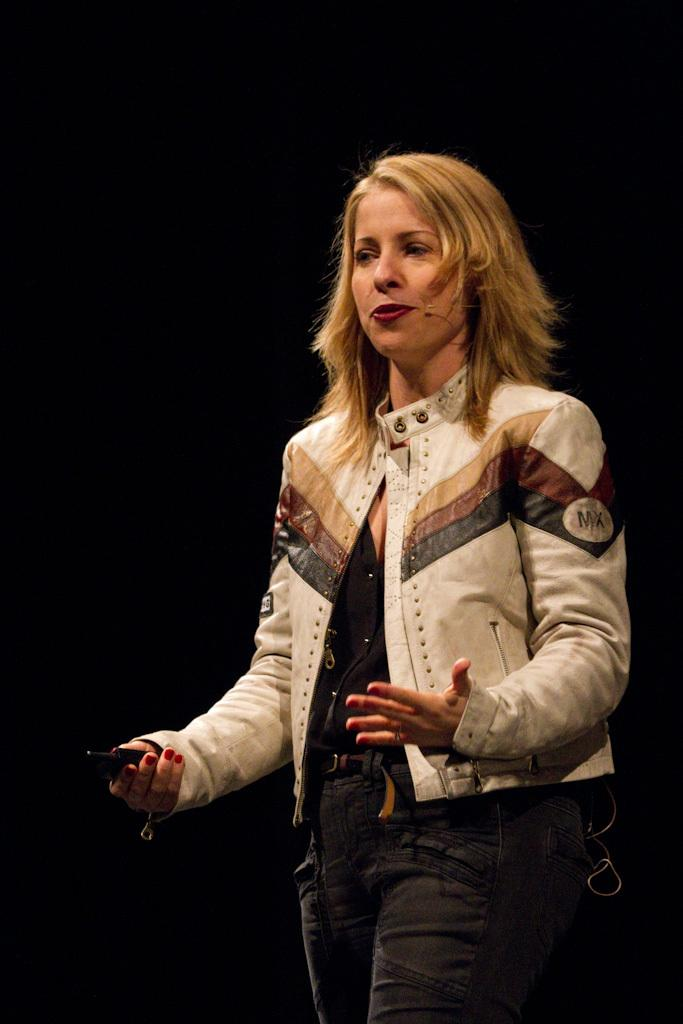Who is the main subject in the image? There is a woman in the image. What is the woman doing in the image? The woman is walking and talking. What is the woman wearing in the image? The woman is wearing a microphone. What is the woman holding in the image? The woman is holding an object. What is the color of the background in the image? The background of the image is black. What type of loaf is the woman holding in the image? There is no loaf present in the image; the woman is holding an object, but it is not specified as a loaf. Can you see a monkey in the image? No, there is no monkey present in the image. 